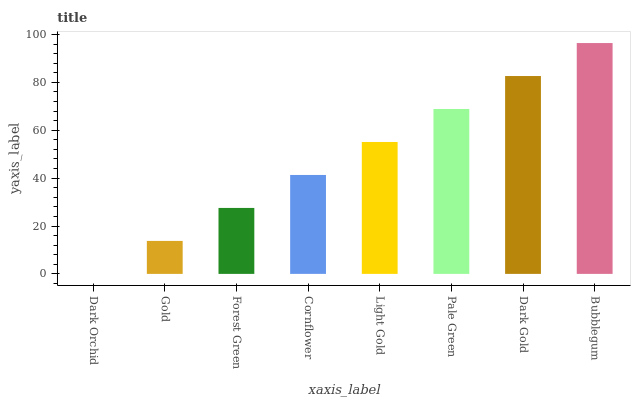Is Dark Orchid the minimum?
Answer yes or no. Yes. Is Bubblegum the maximum?
Answer yes or no. Yes. Is Gold the minimum?
Answer yes or no. No. Is Gold the maximum?
Answer yes or no. No. Is Gold greater than Dark Orchid?
Answer yes or no. Yes. Is Dark Orchid less than Gold?
Answer yes or no. Yes. Is Dark Orchid greater than Gold?
Answer yes or no. No. Is Gold less than Dark Orchid?
Answer yes or no. No. Is Light Gold the high median?
Answer yes or no. Yes. Is Cornflower the low median?
Answer yes or no. Yes. Is Forest Green the high median?
Answer yes or no. No. Is Gold the low median?
Answer yes or no. No. 